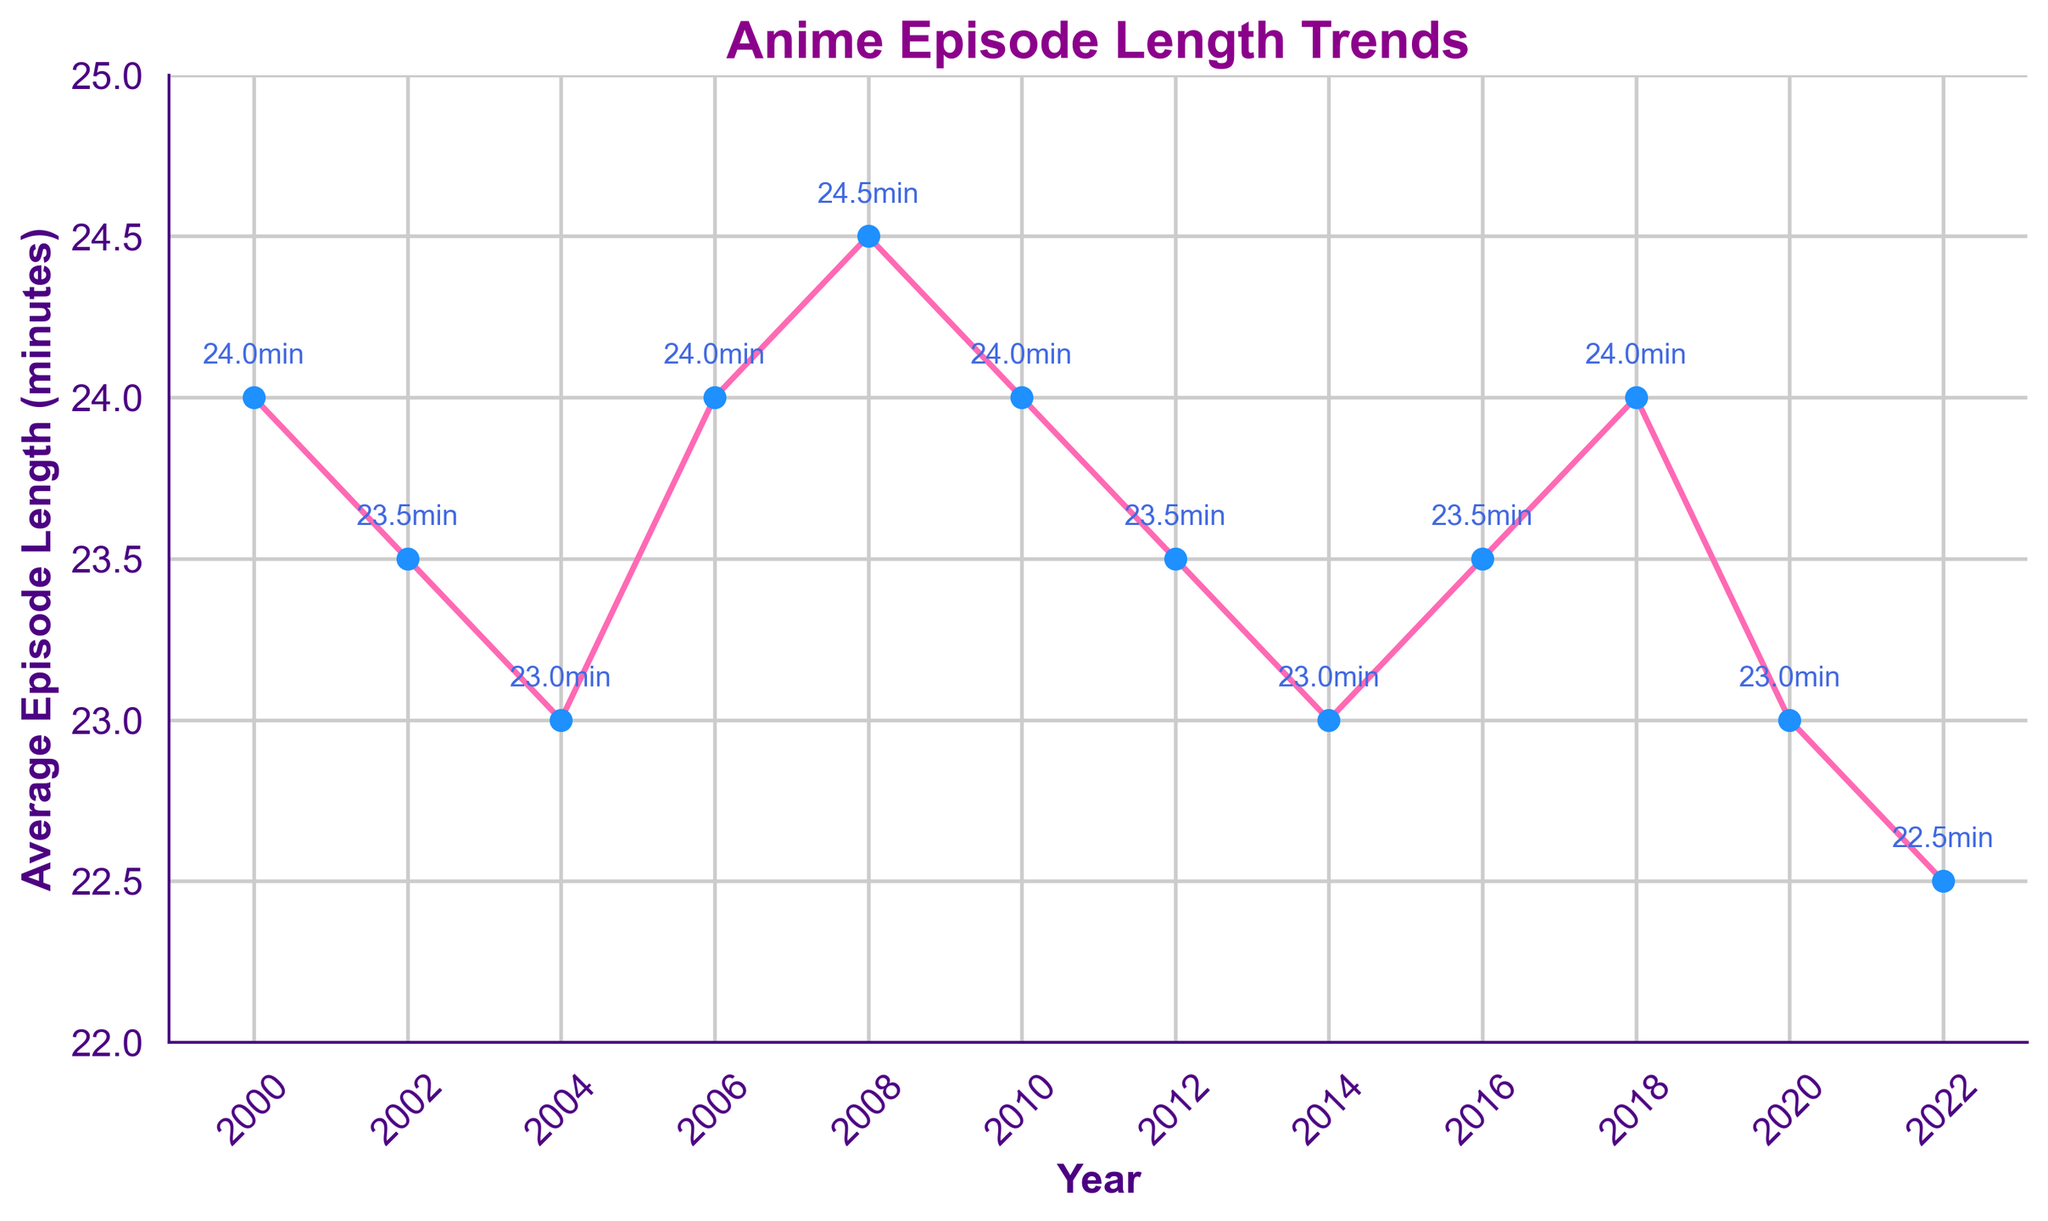What is the average episode length in 2020? Look at the data point for the year 2020 on the chart. The labeled length is 23 minutes.
Answer: 23 minutes In which year was the average episode length the highest? Locate the highest point on the chart. The peak is in 2008 with an episode length of 24.5 minutes.
Answer: 2008 How much did the average episode length change from 2018 to 2022? Note the values for 2018 and 2022. Subtract the 2022 value (22.5) from the 2018 value (24). The change is 24 - 22.5 = 1.5 minutes.
Answer: 1.5 minutes Compare the average episode length in 2006 and 2012. Which year was higher? Look at the points for 2006 and 2012 on the chart. 2006 has 24 minutes, while 2012 has 23.5 minutes. Thus, 2006 was higher.
Answer: 2006 How many times did the average episode length reach exactly 24 minutes? Identify and count the points where the episode length labeled 24. This occurs in the years 2000, 2006, 2010, and 2018.
Answer: 4 times Was the average episode length ever below 23 minutes? Check all the data points on the chart. The lowest value is 22.5 minutes in 2022.
Answer: Yes Calculate the average episode length between 2004 and 2016. Sum the values from 2004 (23), 2006 (24), 2008 (24.5), 2010 (24), 2012 (23.5), 2014 (23), and 2016 (23.5). The total is 165.5 minutes. Divide by the number of years: 165.5/7 ≈ 23.64 minutes.
Answer: 23.64 minutes Which year had the lowest average episode length? Locate the lowest point on the chart. The minimum occurs in 2022 with an episode length of 22.5 minutes.
Answer: 2022 Was the average episode length greater in 2008 or 2018? Compare the lengths for 2008 and 2018. The 2008 length is 24.5 minutes, while 2018 is 24 minutes. Hence, 2008 was greater.
Answer: 2008 